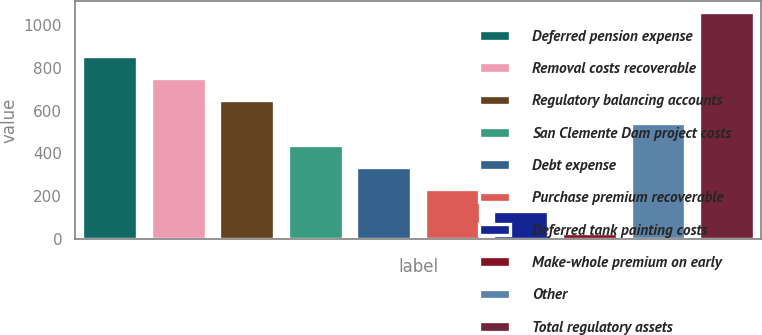Convert chart. <chart><loc_0><loc_0><loc_500><loc_500><bar_chart><fcel>Deferred pension expense<fcel>Removal costs recoverable<fcel>Regulatory balancing accounts<fcel>San Clemente Dam project costs<fcel>Debt expense<fcel>Purchase premium recoverable<fcel>Deferred tank painting costs<fcel>Make-whole premium on early<fcel>Other<fcel>Total regulatory assets<nl><fcel>854.2<fcel>750.8<fcel>647.4<fcel>440.6<fcel>337.2<fcel>233.8<fcel>130.4<fcel>27<fcel>544<fcel>1061<nl></chart> 